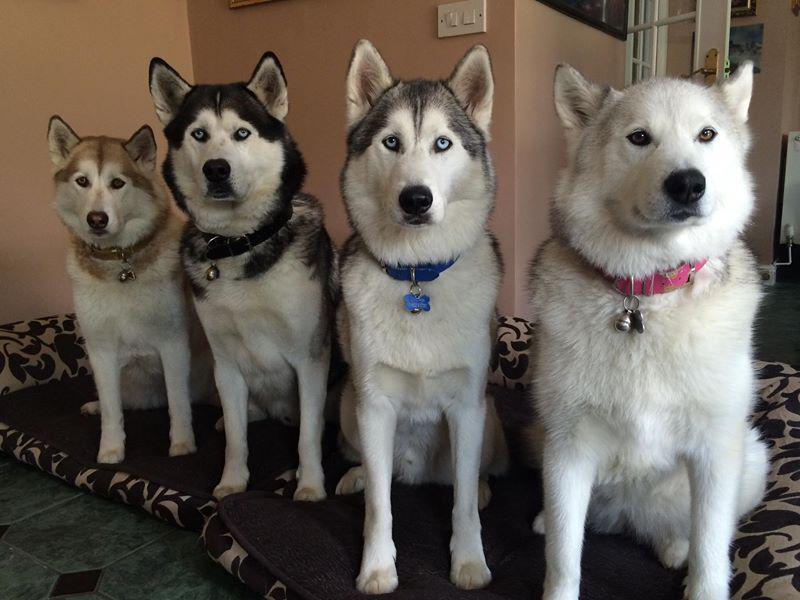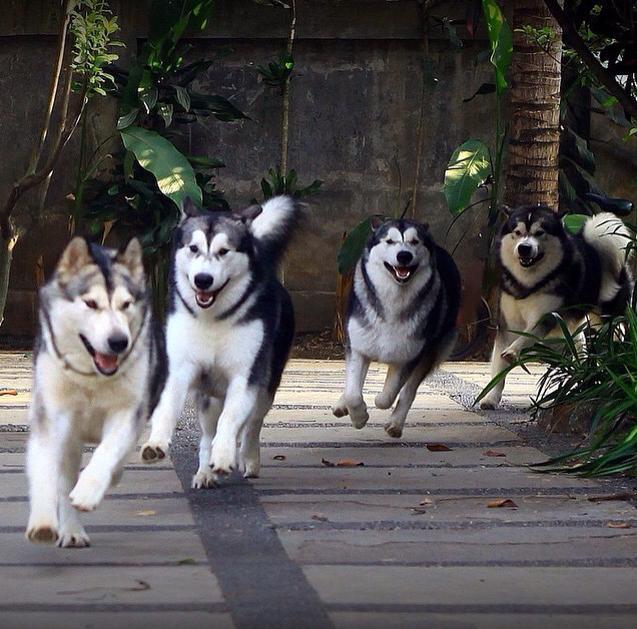The first image is the image on the left, the second image is the image on the right. Considering the images on both sides, is "There are exactly eight dogs." valid? Answer yes or no. Yes. The first image is the image on the left, the second image is the image on the right. Assess this claim about the two images: "One image shows four husky dogs wearing different colored collars with dangling charms, and at least three of the dogs sit upright and face forward.". Correct or not? Answer yes or no. Yes. 